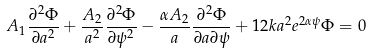<formula> <loc_0><loc_0><loc_500><loc_500>A _ { 1 } \frac { \partial ^ { 2 } \Phi } { \partial a ^ { 2 } } + \frac { A _ { 2 } } { a ^ { 2 } } \frac { \partial ^ { 2 } \Phi } { \partial \psi ^ { 2 } } - \frac { \alpha A _ { 2 } } { a } \frac { \partial ^ { 2 } \Phi } { \partial a \partial \psi } + 1 2 k a ^ { 2 } e ^ { 2 \alpha \psi } \Phi = 0</formula> 